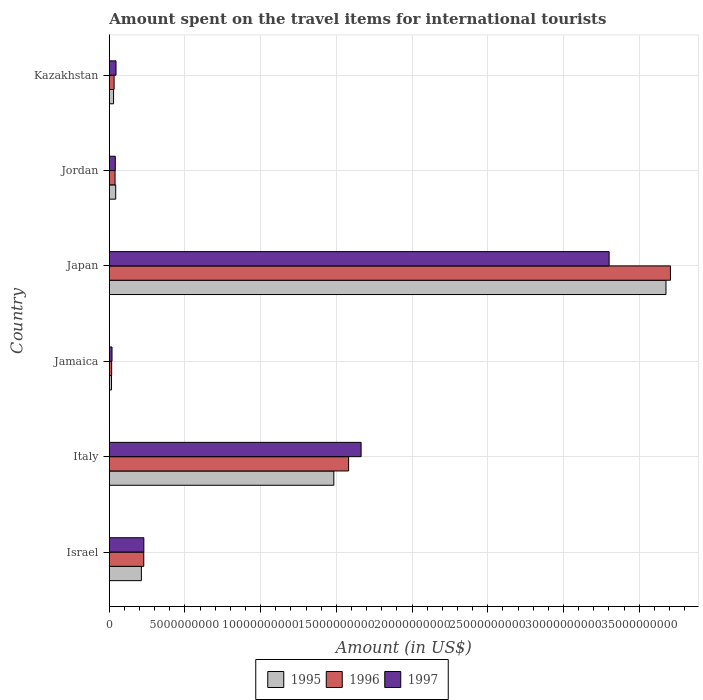Are the number of bars per tick equal to the number of legend labels?
Your answer should be compact. Yes. Are the number of bars on each tick of the Y-axis equal?
Provide a succinct answer. Yes. What is the label of the 6th group of bars from the top?
Offer a very short reply. Israel. What is the amount spent on the travel items for international tourists in 1997 in Japan?
Your response must be concise. 3.30e+1. Across all countries, what is the maximum amount spent on the travel items for international tourists in 1997?
Ensure brevity in your answer.  3.30e+1. Across all countries, what is the minimum amount spent on the travel items for international tourists in 1995?
Your answer should be very brief. 1.48e+08. In which country was the amount spent on the travel items for international tourists in 1996 maximum?
Your answer should be compact. Japan. In which country was the amount spent on the travel items for international tourists in 1997 minimum?
Provide a short and direct response. Jamaica. What is the total amount spent on the travel items for international tourists in 1997 in the graph?
Keep it short and to the point. 5.29e+1. What is the difference between the amount spent on the travel items for international tourists in 1997 in Jamaica and that in Kazakhstan?
Provide a succinct answer. -2.64e+08. What is the difference between the amount spent on the travel items for international tourists in 1996 in Jordan and the amount spent on the travel items for international tourists in 1997 in Kazakhstan?
Offer a very short reply. -6.40e+07. What is the average amount spent on the travel items for international tourists in 1997 per country?
Your answer should be very brief. 8.82e+09. What is the difference between the amount spent on the travel items for international tourists in 1995 and amount spent on the travel items for international tourists in 1996 in Kazakhstan?
Offer a very short reply. -3.60e+07. In how many countries, is the amount spent on the travel items for international tourists in 1995 greater than 8000000000 US$?
Offer a very short reply. 2. What is the ratio of the amount spent on the travel items for international tourists in 1996 in Israel to that in Kazakhstan?
Provide a succinct answer. 7.14. Is the difference between the amount spent on the travel items for international tourists in 1995 in Japan and Jordan greater than the difference between the amount spent on the travel items for international tourists in 1996 in Japan and Jordan?
Keep it short and to the point. No. What is the difference between the highest and the second highest amount spent on the travel items for international tourists in 1996?
Make the answer very short. 2.13e+1. What is the difference between the highest and the lowest amount spent on the travel items for international tourists in 1996?
Make the answer very short. 3.69e+1. In how many countries, is the amount spent on the travel items for international tourists in 1995 greater than the average amount spent on the travel items for international tourists in 1995 taken over all countries?
Provide a short and direct response. 2. What does the 3rd bar from the top in Kazakhstan represents?
Make the answer very short. 1995. What does the 3rd bar from the bottom in Japan represents?
Your response must be concise. 1997. Is it the case that in every country, the sum of the amount spent on the travel items for international tourists in 1996 and amount spent on the travel items for international tourists in 1997 is greater than the amount spent on the travel items for international tourists in 1995?
Offer a terse response. Yes. Are the values on the major ticks of X-axis written in scientific E-notation?
Offer a terse response. No. Does the graph contain grids?
Provide a succinct answer. Yes. How many legend labels are there?
Your answer should be compact. 3. How are the legend labels stacked?
Offer a terse response. Horizontal. What is the title of the graph?
Keep it short and to the point. Amount spent on the travel items for international tourists. Does "1990" appear as one of the legend labels in the graph?
Your answer should be very brief. No. What is the Amount (in US$) of 1995 in Israel?
Your answer should be compact. 2.12e+09. What is the Amount (in US$) in 1996 in Israel?
Your response must be concise. 2.28e+09. What is the Amount (in US$) of 1997 in Israel?
Offer a terse response. 2.28e+09. What is the Amount (in US$) of 1995 in Italy?
Your answer should be very brief. 1.48e+1. What is the Amount (in US$) of 1996 in Italy?
Your response must be concise. 1.58e+1. What is the Amount (in US$) of 1997 in Italy?
Offer a very short reply. 1.66e+1. What is the Amount (in US$) of 1995 in Jamaica?
Your answer should be compact. 1.48e+08. What is the Amount (in US$) of 1996 in Jamaica?
Provide a succinct answer. 1.57e+08. What is the Amount (in US$) of 1997 in Jamaica?
Provide a succinct answer. 1.81e+08. What is the Amount (in US$) of 1995 in Japan?
Your answer should be very brief. 3.68e+1. What is the Amount (in US$) of 1996 in Japan?
Make the answer very short. 3.71e+1. What is the Amount (in US$) of 1997 in Japan?
Ensure brevity in your answer.  3.30e+1. What is the Amount (in US$) of 1995 in Jordan?
Offer a terse response. 4.25e+08. What is the Amount (in US$) of 1996 in Jordan?
Offer a terse response. 3.81e+08. What is the Amount (in US$) in 1997 in Jordan?
Keep it short and to the point. 3.98e+08. What is the Amount (in US$) in 1995 in Kazakhstan?
Your response must be concise. 2.83e+08. What is the Amount (in US$) in 1996 in Kazakhstan?
Provide a short and direct response. 3.19e+08. What is the Amount (in US$) of 1997 in Kazakhstan?
Provide a short and direct response. 4.45e+08. Across all countries, what is the maximum Amount (in US$) of 1995?
Offer a very short reply. 3.68e+1. Across all countries, what is the maximum Amount (in US$) of 1996?
Your answer should be compact. 3.71e+1. Across all countries, what is the maximum Amount (in US$) in 1997?
Offer a very short reply. 3.30e+1. Across all countries, what is the minimum Amount (in US$) in 1995?
Provide a succinct answer. 1.48e+08. Across all countries, what is the minimum Amount (in US$) in 1996?
Ensure brevity in your answer.  1.57e+08. Across all countries, what is the minimum Amount (in US$) in 1997?
Your response must be concise. 1.81e+08. What is the total Amount (in US$) of 1995 in the graph?
Offer a terse response. 5.46e+1. What is the total Amount (in US$) in 1996 in the graph?
Provide a short and direct response. 5.60e+1. What is the total Amount (in US$) in 1997 in the graph?
Your answer should be very brief. 5.29e+1. What is the difference between the Amount (in US$) of 1995 in Israel and that in Italy?
Your answer should be very brief. -1.27e+1. What is the difference between the Amount (in US$) in 1996 in Israel and that in Italy?
Ensure brevity in your answer.  -1.35e+1. What is the difference between the Amount (in US$) in 1997 in Israel and that in Italy?
Provide a short and direct response. -1.43e+1. What is the difference between the Amount (in US$) of 1995 in Israel and that in Jamaica?
Your answer should be very brief. 1.97e+09. What is the difference between the Amount (in US$) of 1996 in Israel and that in Jamaica?
Make the answer very short. 2.12e+09. What is the difference between the Amount (in US$) of 1997 in Israel and that in Jamaica?
Make the answer very short. 2.10e+09. What is the difference between the Amount (in US$) in 1995 in Israel and that in Japan?
Your answer should be compact. -3.46e+1. What is the difference between the Amount (in US$) of 1996 in Israel and that in Japan?
Your answer should be compact. -3.48e+1. What is the difference between the Amount (in US$) in 1997 in Israel and that in Japan?
Your answer should be compact. -3.07e+1. What is the difference between the Amount (in US$) in 1995 in Israel and that in Jordan?
Offer a very short reply. 1.70e+09. What is the difference between the Amount (in US$) in 1996 in Israel and that in Jordan?
Give a very brief answer. 1.90e+09. What is the difference between the Amount (in US$) in 1997 in Israel and that in Jordan?
Provide a short and direct response. 1.88e+09. What is the difference between the Amount (in US$) in 1995 in Israel and that in Kazakhstan?
Make the answer very short. 1.84e+09. What is the difference between the Amount (in US$) of 1996 in Israel and that in Kazakhstan?
Your answer should be compact. 1.96e+09. What is the difference between the Amount (in US$) in 1997 in Israel and that in Kazakhstan?
Keep it short and to the point. 1.84e+09. What is the difference between the Amount (in US$) in 1995 in Italy and that in Jamaica?
Offer a terse response. 1.47e+1. What is the difference between the Amount (in US$) of 1996 in Italy and that in Jamaica?
Your response must be concise. 1.56e+1. What is the difference between the Amount (in US$) of 1997 in Italy and that in Jamaica?
Your answer should be compact. 1.64e+1. What is the difference between the Amount (in US$) in 1995 in Italy and that in Japan?
Ensure brevity in your answer.  -2.19e+1. What is the difference between the Amount (in US$) of 1996 in Italy and that in Japan?
Provide a short and direct response. -2.13e+1. What is the difference between the Amount (in US$) of 1997 in Italy and that in Japan?
Make the answer very short. -1.64e+1. What is the difference between the Amount (in US$) in 1995 in Italy and that in Jordan?
Your response must be concise. 1.44e+1. What is the difference between the Amount (in US$) in 1996 in Italy and that in Jordan?
Give a very brief answer. 1.54e+1. What is the difference between the Amount (in US$) of 1997 in Italy and that in Jordan?
Your answer should be compact. 1.62e+1. What is the difference between the Amount (in US$) of 1995 in Italy and that in Kazakhstan?
Provide a succinct answer. 1.45e+1. What is the difference between the Amount (in US$) in 1996 in Italy and that in Kazakhstan?
Provide a succinct answer. 1.55e+1. What is the difference between the Amount (in US$) in 1997 in Italy and that in Kazakhstan?
Ensure brevity in your answer.  1.62e+1. What is the difference between the Amount (in US$) in 1995 in Jamaica and that in Japan?
Provide a succinct answer. -3.66e+1. What is the difference between the Amount (in US$) in 1996 in Jamaica and that in Japan?
Provide a succinct answer. -3.69e+1. What is the difference between the Amount (in US$) of 1997 in Jamaica and that in Japan?
Your answer should be compact. -3.28e+1. What is the difference between the Amount (in US$) of 1995 in Jamaica and that in Jordan?
Offer a terse response. -2.77e+08. What is the difference between the Amount (in US$) of 1996 in Jamaica and that in Jordan?
Provide a succinct answer. -2.24e+08. What is the difference between the Amount (in US$) in 1997 in Jamaica and that in Jordan?
Your answer should be compact. -2.17e+08. What is the difference between the Amount (in US$) of 1995 in Jamaica and that in Kazakhstan?
Keep it short and to the point. -1.35e+08. What is the difference between the Amount (in US$) of 1996 in Jamaica and that in Kazakhstan?
Provide a short and direct response. -1.62e+08. What is the difference between the Amount (in US$) in 1997 in Jamaica and that in Kazakhstan?
Ensure brevity in your answer.  -2.64e+08. What is the difference between the Amount (in US$) of 1995 in Japan and that in Jordan?
Give a very brief answer. 3.63e+1. What is the difference between the Amount (in US$) of 1996 in Japan and that in Jordan?
Ensure brevity in your answer.  3.67e+1. What is the difference between the Amount (in US$) of 1997 in Japan and that in Jordan?
Provide a succinct answer. 3.26e+1. What is the difference between the Amount (in US$) of 1995 in Japan and that in Kazakhstan?
Keep it short and to the point. 3.65e+1. What is the difference between the Amount (in US$) in 1996 in Japan and that in Kazakhstan?
Make the answer very short. 3.67e+1. What is the difference between the Amount (in US$) of 1997 in Japan and that in Kazakhstan?
Keep it short and to the point. 3.26e+1. What is the difference between the Amount (in US$) in 1995 in Jordan and that in Kazakhstan?
Give a very brief answer. 1.42e+08. What is the difference between the Amount (in US$) in 1996 in Jordan and that in Kazakhstan?
Offer a terse response. 6.20e+07. What is the difference between the Amount (in US$) in 1997 in Jordan and that in Kazakhstan?
Provide a succinct answer. -4.70e+07. What is the difference between the Amount (in US$) of 1995 in Israel and the Amount (in US$) of 1996 in Italy?
Provide a short and direct response. -1.37e+1. What is the difference between the Amount (in US$) in 1995 in Israel and the Amount (in US$) in 1997 in Italy?
Ensure brevity in your answer.  -1.45e+1. What is the difference between the Amount (in US$) of 1996 in Israel and the Amount (in US$) of 1997 in Italy?
Your answer should be compact. -1.44e+1. What is the difference between the Amount (in US$) of 1995 in Israel and the Amount (in US$) of 1996 in Jamaica?
Make the answer very short. 1.96e+09. What is the difference between the Amount (in US$) of 1995 in Israel and the Amount (in US$) of 1997 in Jamaica?
Offer a terse response. 1.94e+09. What is the difference between the Amount (in US$) in 1996 in Israel and the Amount (in US$) in 1997 in Jamaica?
Your answer should be very brief. 2.10e+09. What is the difference between the Amount (in US$) of 1995 in Israel and the Amount (in US$) of 1996 in Japan?
Your answer should be compact. -3.49e+1. What is the difference between the Amount (in US$) in 1995 in Israel and the Amount (in US$) in 1997 in Japan?
Ensure brevity in your answer.  -3.09e+1. What is the difference between the Amount (in US$) of 1996 in Israel and the Amount (in US$) of 1997 in Japan?
Provide a short and direct response. -3.07e+1. What is the difference between the Amount (in US$) in 1995 in Israel and the Amount (in US$) in 1996 in Jordan?
Your response must be concise. 1.74e+09. What is the difference between the Amount (in US$) in 1995 in Israel and the Amount (in US$) in 1997 in Jordan?
Keep it short and to the point. 1.72e+09. What is the difference between the Amount (in US$) of 1996 in Israel and the Amount (in US$) of 1997 in Jordan?
Your answer should be compact. 1.88e+09. What is the difference between the Amount (in US$) of 1995 in Israel and the Amount (in US$) of 1996 in Kazakhstan?
Give a very brief answer. 1.80e+09. What is the difference between the Amount (in US$) in 1995 in Israel and the Amount (in US$) in 1997 in Kazakhstan?
Provide a succinct answer. 1.68e+09. What is the difference between the Amount (in US$) of 1996 in Israel and the Amount (in US$) of 1997 in Kazakhstan?
Give a very brief answer. 1.83e+09. What is the difference between the Amount (in US$) of 1995 in Italy and the Amount (in US$) of 1996 in Jamaica?
Provide a succinct answer. 1.47e+1. What is the difference between the Amount (in US$) of 1995 in Italy and the Amount (in US$) of 1997 in Jamaica?
Keep it short and to the point. 1.46e+1. What is the difference between the Amount (in US$) in 1996 in Italy and the Amount (in US$) in 1997 in Jamaica?
Keep it short and to the point. 1.56e+1. What is the difference between the Amount (in US$) of 1995 in Italy and the Amount (in US$) of 1996 in Japan?
Your answer should be very brief. -2.22e+1. What is the difference between the Amount (in US$) of 1995 in Italy and the Amount (in US$) of 1997 in Japan?
Offer a terse response. -1.82e+1. What is the difference between the Amount (in US$) of 1996 in Italy and the Amount (in US$) of 1997 in Japan?
Provide a short and direct response. -1.72e+1. What is the difference between the Amount (in US$) of 1995 in Italy and the Amount (in US$) of 1996 in Jordan?
Ensure brevity in your answer.  1.44e+1. What is the difference between the Amount (in US$) of 1995 in Italy and the Amount (in US$) of 1997 in Jordan?
Make the answer very short. 1.44e+1. What is the difference between the Amount (in US$) in 1996 in Italy and the Amount (in US$) in 1997 in Jordan?
Your answer should be very brief. 1.54e+1. What is the difference between the Amount (in US$) in 1995 in Italy and the Amount (in US$) in 1996 in Kazakhstan?
Your answer should be compact. 1.45e+1. What is the difference between the Amount (in US$) of 1995 in Italy and the Amount (in US$) of 1997 in Kazakhstan?
Your response must be concise. 1.44e+1. What is the difference between the Amount (in US$) of 1996 in Italy and the Amount (in US$) of 1997 in Kazakhstan?
Your answer should be compact. 1.54e+1. What is the difference between the Amount (in US$) in 1995 in Jamaica and the Amount (in US$) in 1996 in Japan?
Offer a terse response. -3.69e+1. What is the difference between the Amount (in US$) of 1995 in Jamaica and the Amount (in US$) of 1997 in Japan?
Ensure brevity in your answer.  -3.29e+1. What is the difference between the Amount (in US$) in 1996 in Jamaica and the Amount (in US$) in 1997 in Japan?
Provide a short and direct response. -3.29e+1. What is the difference between the Amount (in US$) in 1995 in Jamaica and the Amount (in US$) in 1996 in Jordan?
Make the answer very short. -2.33e+08. What is the difference between the Amount (in US$) in 1995 in Jamaica and the Amount (in US$) in 1997 in Jordan?
Ensure brevity in your answer.  -2.50e+08. What is the difference between the Amount (in US$) of 1996 in Jamaica and the Amount (in US$) of 1997 in Jordan?
Offer a terse response. -2.41e+08. What is the difference between the Amount (in US$) of 1995 in Jamaica and the Amount (in US$) of 1996 in Kazakhstan?
Offer a terse response. -1.71e+08. What is the difference between the Amount (in US$) of 1995 in Jamaica and the Amount (in US$) of 1997 in Kazakhstan?
Your response must be concise. -2.97e+08. What is the difference between the Amount (in US$) of 1996 in Jamaica and the Amount (in US$) of 1997 in Kazakhstan?
Your answer should be very brief. -2.88e+08. What is the difference between the Amount (in US$) of 1995 in Japan and the Amount (in US$) of 1996 in Jordan?
Keep it short and to the point. 3.64e+1. What is the difference between the Amount (in US$) in 1995 in Japan and the Amount (in US$) in 1997 in Jordan?
Provide a short and direct response. 3.64e+1. What is the difference between the Amount (in US$) in 1996 in Japan and the Amount (in US$) in 1997 in Jordan?
Your answer should be very brief. 3.67e+1. What is the difference between the Amount (in US$) in 1995 in Japan and the Amount (in US$) in 1996 in Kazakhstan?
Your answer should be very brief. 3.64e+1. What is the difference between the Amount (in US$) of 1995 in Japan and the Amount (in US$) of 1997 in Kazakhstan?
Give a very brief answer. 3.63e+1. What is the difference between the Amount (in US$) in 1996 in Japan and the Amount (in US$) in 1997 in Kazakhstan?
Provide a short and direct response. 3.66e+1. What is the difference between the Amount (in US$) in 1995 in Jordan and the Amount (in US$) in 1996 in Kazakhstan?
Give a very brief answer. 1.06e+08. What is the difference between the Amount (in US$) of 1995 in Jordan and the Amount (in US$) of 1997 in Kazakhstan?
Offer a terse response. -2.00e+07. What is the difference between the Amount (in US$) in 1996 in Jordan and the Amount (in US$) in 1997 in Kazakhstan?
Make the answer very short. -6.40e+07. What is the average Amount (in US$) in 1995 per country?
Provide a short and direct response. 9.09e+09. What is the average Amount (in US$) of 1996 per country?
Make the answer very short. 9.33e+09. What is the average Amount (in US$) of 1997 per country?
Give a very brief answer. 8.82e+09. What is the difference between the Amount (in US$) of 1995 and Amount (in US$) of 1996 in Israel?
Provide a succinct answer. -1.58e+08. What is the difference between the Amount (in US$) in 1995 and Amount (in US$) in 1997 in Israel?
Offer a very short reply. -1.63e+08. What is the difference between the Amount (in US$) in 1996 and Amount (in US$) in 1997 in Israel?
Keep it short and to the point. -5.00e+06. What is the difference between the Amount (in US$) of 1995 and Amount (in US$) of 1996 in Italy?
Keep it short and to the point. -9.76e+08. What is the difference between the Amount (in US$) in 1995 and Amount (in US$) in 1997 in Italy?
Make the answer very short. -1.80e+09. What is the difference between the Amount (in US$) of 1996 and Amount (in US$) of 1997 in Italy?
Keep it short and to the point. -8.26e+08. What is the difference between the Amount (in US$) in 1995 and Amount (in US$) in 1996 in Jamaica?
Your answer should be very brief. -9.00e+06. What is the difference between the Amount (in US$) of 1995 and Amount (in US$) of 1997 in Jamaica?
Offer a terse response. -3.30e+07. What is the difference between the Amount (in US$) of 1996 and Amount (in US$) of 1997 in Jamaica?
Keep it short and to the point. -2.40e+07. What is the difference between the Amount (in US$) in 1995 and Amount (in US$) in 1996 in Japan?
Your answer should be very brief. -2.94e+08. What is the difference between the Amount (in US$) of 1995 and Amount (in US$) of 1997 in Japan?
Your answer should be very brief. 3.76e+09. What is the difference between the Amount (in US$) of 1996 and Amount (in US$) of 1997 in Japan?
Give a very brief answer. 4.05e+09. What is the difference between the Amount (in US$) of 1995 and Amount (in US$) of 1996 in Jordan?
Your answer should be very brief. 4.40e+07. What is the difference between the Amount (in US$) of 1995 and Amount (in US$) of 1997 in Jordan?
Your answer should be compact. 2.70e+07. What is the difference between the Amount (in US$) of 1996 and Amount (in US$) of 1997 in Jordan?
Ensure brevity in your answer.  -1.70e+07. What is the difference between the Amount (in US$) of 1995 and Amount (in US$) of 1996 in Kazakhstan?
Your answer should be very brief. -3.60e+07. What is the difference between the Amount (in US$) of 1995 and Amount (in US$) of 1997 in Kazakhstan?
Your answer should be compact. -1.62e+08. What is the difference between the Amount (in US$) of 1996 and Amount (in US$) of 1997 in Kazakhstan?
Provide a short and direct response. -1.26e+08. What is the ratio of the Amount (in US$) of 1995 in Israel to that in Italy?
Your response must be concise. 0.14. What is the ratio of the Amount (in US$) in 1996 in Israel to that in Italy?
Ensure brevity in your answer.  0.14. What is the ratio of the Amount (in US$) in 1997 in Israel to that in Italy?
Your answer should be compact. 0.14. What is the ratio of the Amount (in US$) in 1995 in Israel to that in Jamaica?
Keep it short and to the point. 14.32. What is the ratio of the Amount (in US$) in 1996 in Israel to that in Jamaica?
Keep it short and to the point. 14.51. What is the ratio of the Amount (in US$) in 1997 in Israel to that in Jamaica?
Provide a short and direct response. 12.61. What is the ratio of the Amount (in US$) in 1995 in Israel to that in Japan?
Provide a short and direct response. 0.06. What is the ratio of the Amount (in US$) in 1996 in Israel to that in Japan?
Provide a short and direct response. 0.06. What is the ratio of the Amount (in US$) in 1997 in Israel to that in Japan?
Keep it short and to the point. 0.07. What is the ratio of the Amount (in US$) in 1995 in Israel to that in Jordan?
Give a very brief answer. 4.99. What is the ratio of the Amount (in US$) of 1996 in Israel to that in Jordan?
Your answer should be very brief. 5.98. What is the ratio of the Amount (in US$) in 1997 in Israel to that in Jordan?
Provide a short and direct response. 5.74. What is the ratio of the Amount (in US$) of 1995 in Israel to that in Kazakhstan?
Your answer should be compact. 7.49. What is the ratio of the Amount (in US$) of 1996 in Israel to that in Kazakhstan?
Offer a very short reply. 7.14. What is the ratio of the Amount (in US$) of 1997 in Israel to that in Kazakhstan?
Your answer should be very brief. 5.13. What is the ratio of the Amount (in US$) in 1995 in Italy to that in Jamaica?
Ensure brevity in your answer.  100.2. What is the ratio of the Amount (in US$) of 1996 in Italy to that in Jamaica?
Ensure brevity in your answer.  100.67. What is the ratio of the Amount (in US$) of 1997 in Italy to that in Jamaica?
Make the answer very short. 91.88. What is the ratio of the Amount (in US$) of 1995 in Italy to that in Japan?
Offer a very short reply. 0.4. What is the ratio of the Amount (in US$) in 1996 in Italy to that in Japan?
Ensure brevity in your answer.  0.43. What is the ratio of the Amount (in US$) in 1997 in Italy to that in Japan?
Provide a succinct answer. 0.5. What is the ratio of the Amount (in US$) in 1995 in Italy to that in Jordan?
Make the answer very short. 34.89. What is the ratio of the Amount (in US$) in 1996 in Italy to that in Jordan?
Your answer should be compact. 41.48. What is the ratio of the Amount (in US$) of 1997 in Italy to that in Jordan?
Your answer should be very brief. 41.79. What is the ratio of the Amount (in US$) of 1995 in Italy to that in Kazakhstan?
Give a very brief answer. 52.4. What is the ratio of the Amount (in US$) in 1996 in Italy to that in Kazakhstan?
Provide a succinct answer. 49.55. What is the ratio of the Amount (in US$) of 1997 in Italy to that in Kazakhstan?
Ensure brevity in your answer.  37.37. What is the ratio of the Amount (in US$) in 1995 in Jamaica to that in Japan?
Your answer should be compact. 0. What is the ratio of the Amount (in US$) in 1996 in Jamaica to that in Japan?
Offer a terse response. 0. What is the ratio of the Amount (in US$) of 1997 in Jamaica to that in Japan?
Offer a very short reply. 0.01. What is the ratio of the Amount (in US$) in 1995 in Jamaica to that in Jordan?
Make the answer very short. 0.35. What is the ratio of the Amount (in US$) of 1996 in Jamaica to that in Jordan?
Provide a succinct answer. 0.41. What is the ratio of the Amount (in US$) of 1997 in Jamaica to that in Jordan?
Keep it short and to the point. 0.45. What is the ratio of the Amount (in US$) of 1995 in Jamaica to that in Kazakhstan?
Provide a short and direct response. 0.52. What is the ratio of the Amount (in US$) in 1996 in Jamaica to that in Kazakhstan?
Give a very brief answer. 0.49. What is the ratio of the Amount (in US$) in 1997 in Jamaica to that in Kazakhstan?
Keep it short and to the point. 0.41. What is the ratio of the Amount (in US$) of 1995 in Japan to that in Jordan?
Your response must be concise. 86.5. What is the ratio of the Amount (in US$) of 1996 in Japan to that in Jordan?
Give a very brief answer. 97.27. What is the ratio of the Amount (in US$) of 1997 in Japan to that in Jordan?
Your answer should be very brief. 82.94. What is the ratio of the Amount (in US$) of 1995 in Japan to that in Kazakhstan?
Offer a very short reply. 129.91. What is the ratio of the Amount (in US$) in 1996 in Japan to that in Kazakhstan?
Make the answer very short. 116.17. What is the ratio of the Amount (in US$) of 1997 in Japan to that in Kazakhstan?
Provide a short and direct response. 74.18. What is the ratio of the Amount (in US$) in 1995 in Jordan to that in Kazakhstan?
Give a very brief answer. 1.5. What is the ratio of the Amount (in US$) of 1996 in Jordan to that in Kazakhstan?
Provide a short and direct response. 1.19. What is the ratio of the Amount (in US$) of 1997 in Jordan to that in Kazakhstan?
Your response must be concise. 0.89. What is the difference between the highest and the second highest Amount (in US$) of 1995?
Offer a very short reply. 2.19e+1. What is the difference between the highest and the second highest Amount (in US$) of 1996?
Your answer should be very brief. 2.13e+1. What is the difference between the highest and the second highest Amount (in US$) in 1997?
Your response must be concise. 1.64e+1. What is the difference between the highest and the lowest Amount (in US$) in 1995?
Offer a very short reply. 3.66e+1. What is the difference between the highest and the lowest Amount (in US$) of 1996?
Give a very brief answer. 3.69e+1. What is the difference between the highest and the lowest Amount (in US$) of 1997?
Your answer should be very brief. 3.28e+1. 